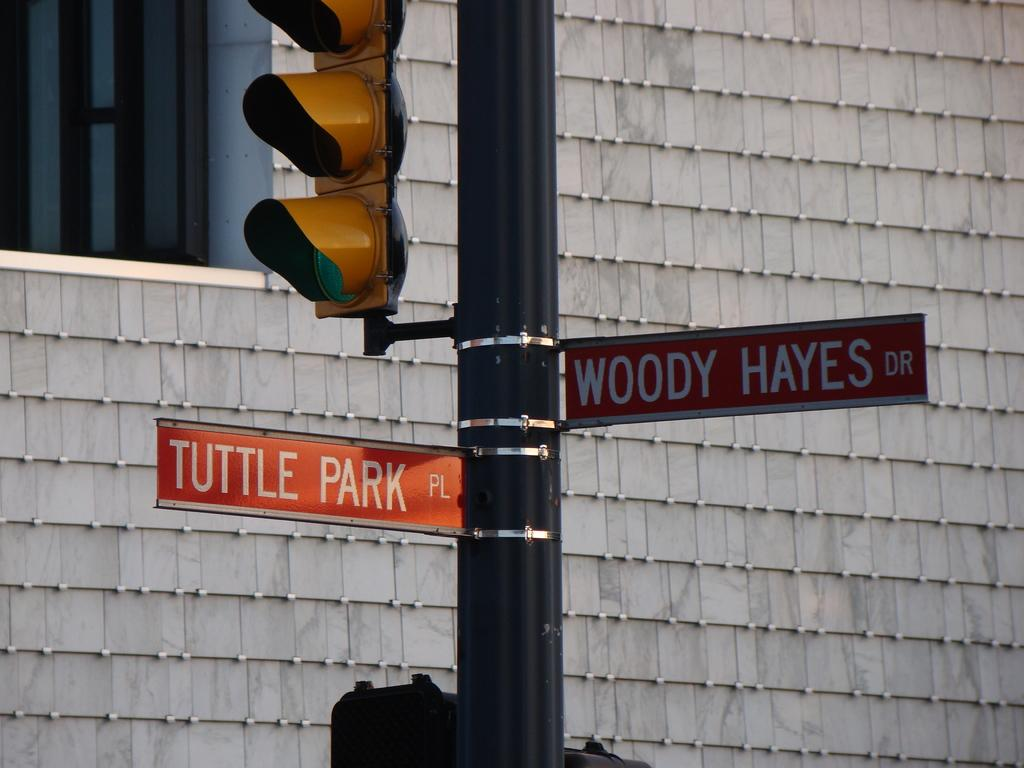Provide a one-sentence caption for the provided image. A sign pole at a crossing with one sign pointing to Tuttle Park and the other to Woody Hayes Dr. 